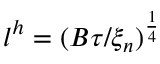<formula> <loc_0><loc_0><loc_500><loc_500>l ^ { h } = ( B \tau / \xi _ { n } ) ^ { \frac { 1 } { 4 } }</formula> 